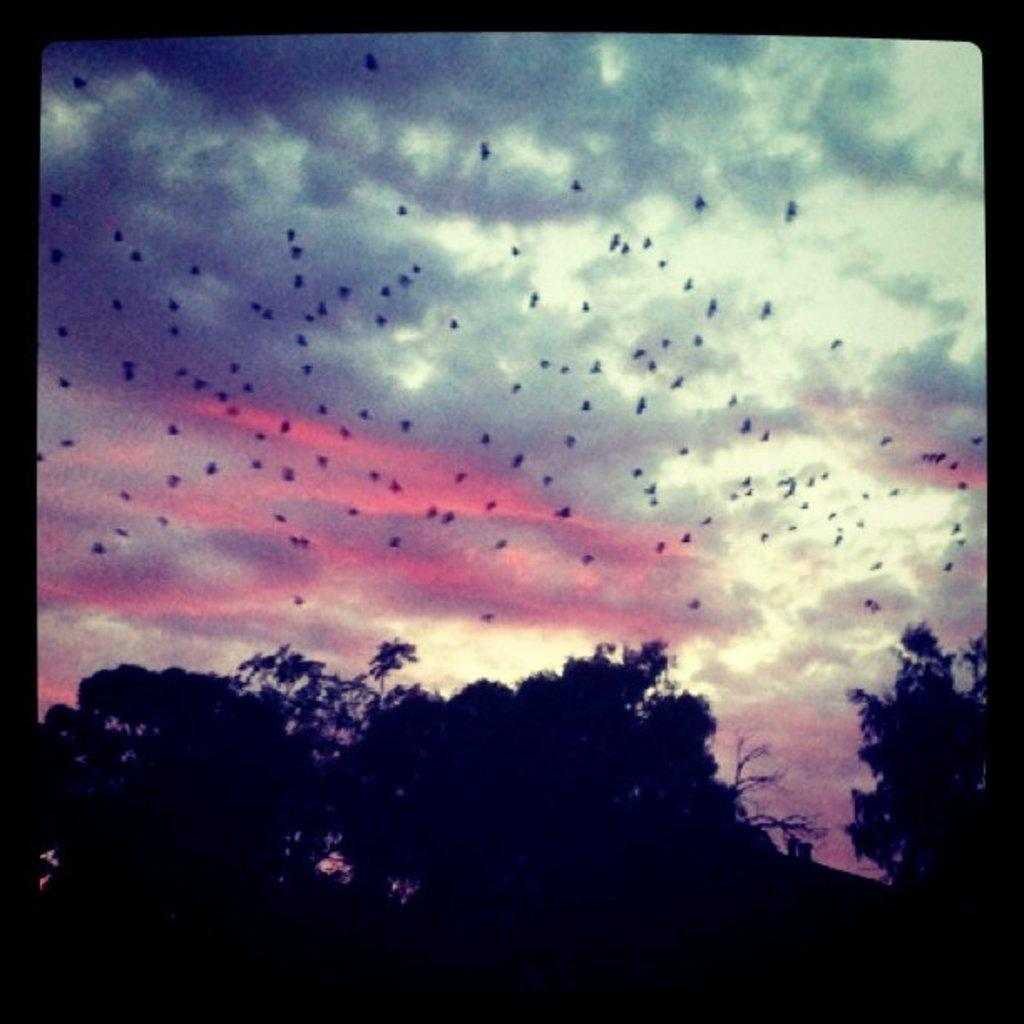What type of vegetation can be seen in the image? There are trees in the image. What is happening in the sky in the image? Birds are flying in the sky. What is the condition of the sky in the image? The sky is cloudy. How would you describe the lighting in the image? The image appears to be dark. What type of dirt is being used to make a profit in the image? There is no dirt or profit-making activity present in the image. What type of sweater is being worn by the birds in the image? There are no birds wearing sweaters in the image; the birds are flying without any clothing. 